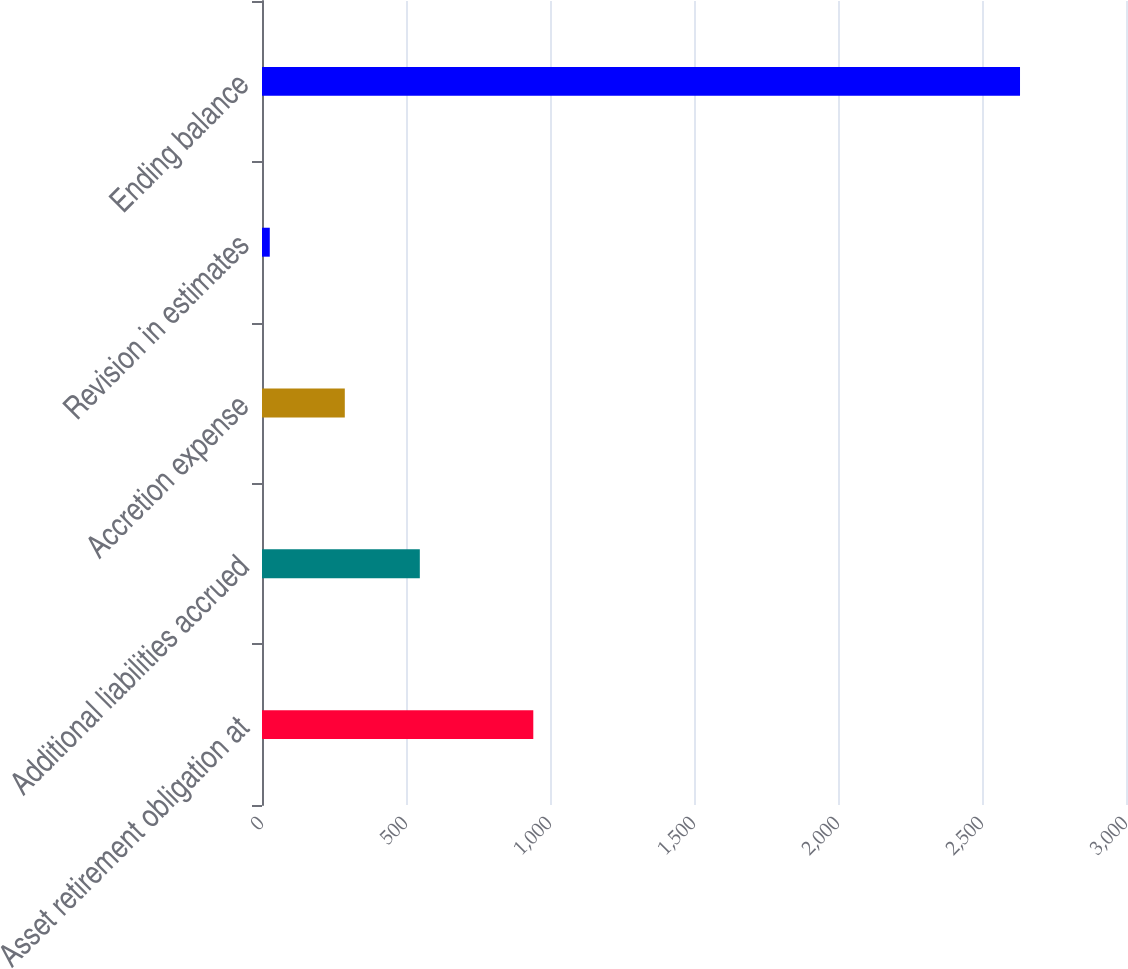Convert chart. <chart><loc_0><loc_0><loc_500><loc_500><bar_chart><fcel>Asset retirement obligation at<fcel>Additional liabilities accrued<fcel>Accretion expense<fcel>Revision in estimates<fcel>Ending balance<nl><fcel>942<fcel>548<fcel>287.5<fcel>27<fcel>2632<nl></chart> 